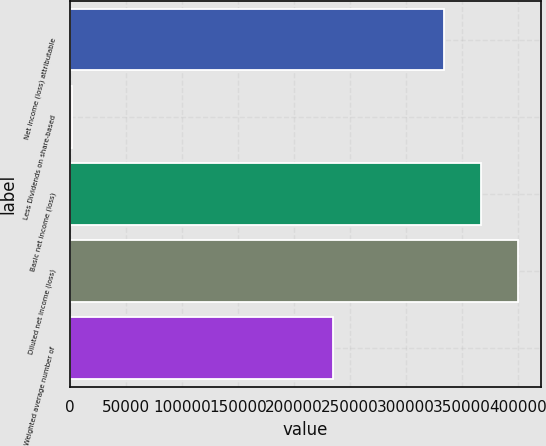Convert chart to OTSL. <chart><loc_0><loc_0><loc_500><loc_500><bar_chart><fcel>Net income (loss) attributable<fcel>Less Dividends on share-based<fcel>Basic net income (loss)<fcel>Diluted net income (loss)<fcel>Weighted average number of<nl><fcel>333601<fcel>1759<fcel>366961<fcel>400321<fcel>234566<nl></chart> 